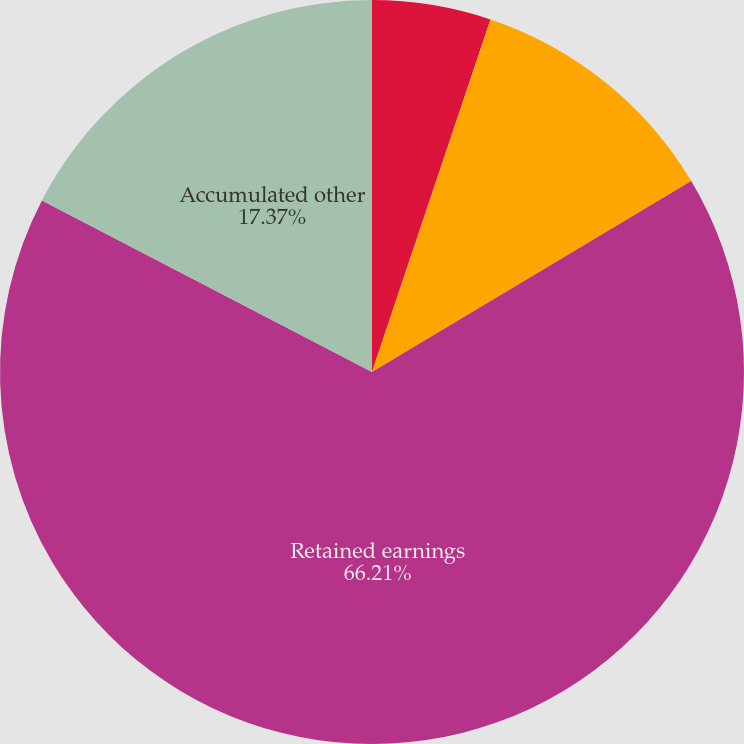Convert chart to OTSL. <chart><loc_0><loc_0><loc_500><loc_500><pie_chart><fcel>Other assets<fcel>Pension and postretirement<fcel>Retained earnings<fcel>Accumulated other<nl><fcel>5.16%<fcel>11.26%<fcel>66.21%<fcel>17.37%<nl></chart> 